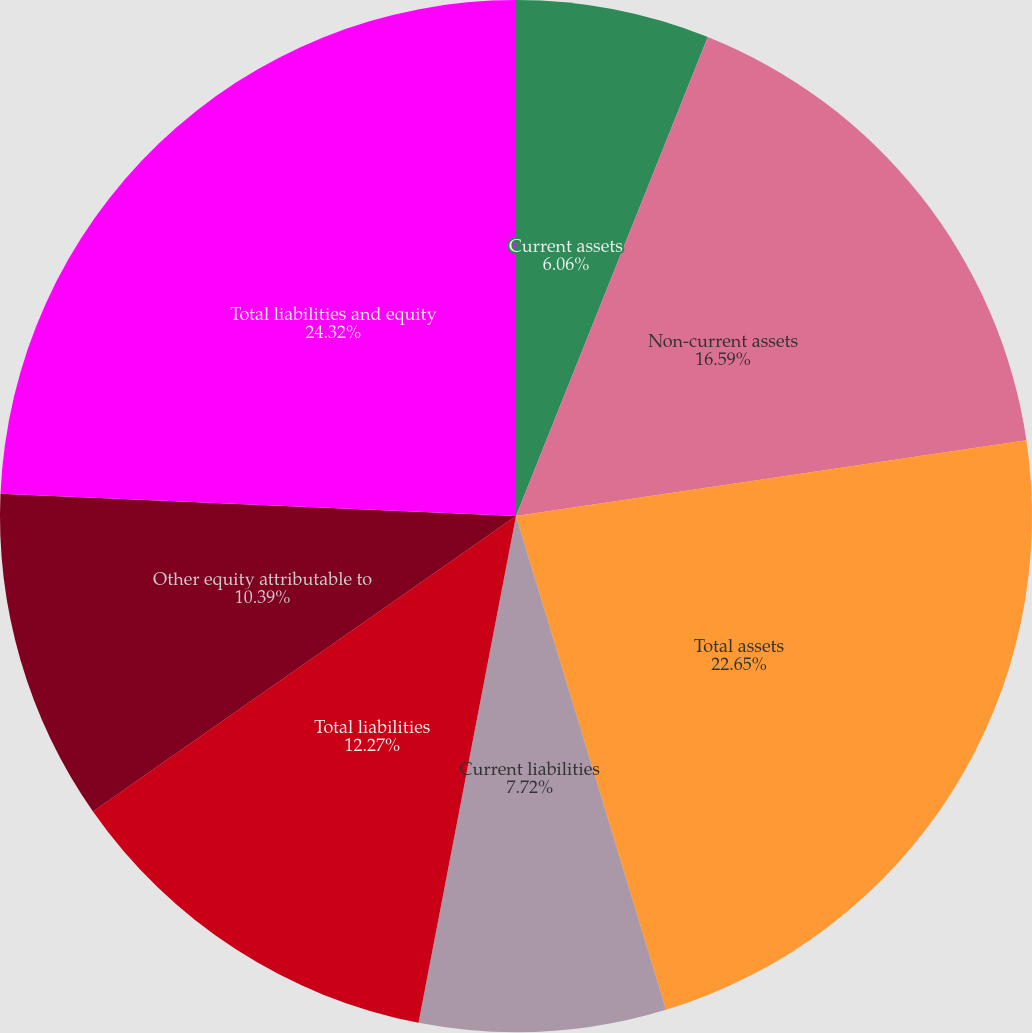Convert chart. <chart><loc_0><loc_0><loc_500><loc_500><pie_chart><fcel>Current assets<fcel>Non-current assets<fcel>Total assets<fcel>Current liabilities<fcel>Total liabilities<fcel>Other equity attributable to<fcel>Total liabilities and equity<nl><fcel>6.06%<fcel>16.59%<fcel>22.65%<fcel>7.72%<fcel>12.27%<fcel>10.39%<fcel>24.31%<nl></chart> 